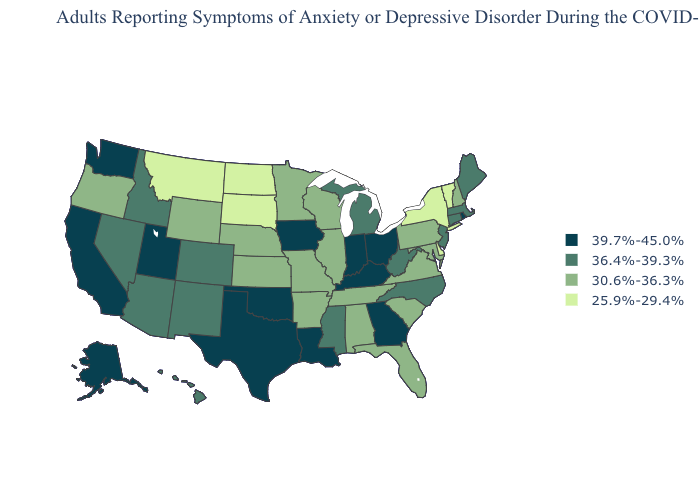Does Florida have the same value as North Dakota?
Answer briefly. No. Name the states that have a value in the range 39.7%-45.0%?
Answer briefly. Alaska, California, Georgia, Indiana, Iowa, Kentucky, Louisiana, Ohio, Oklahoma, Rhode Island, Texas, Utah, Washington. Does the first symbol in the legend represent the smallest category?
Keep it brief. No. Which states have the highest value in the USA?
Answer briefly. Alaska, California, Georgia, Indiana, Iowa, Kentucky, Louisiana, Ohio, Oklahoma, Rhode Island, Texas, Utah, Washington. Name the states that have a value in the range 30.6%-36.3%?
Keep it brief. Alabama, Arkansas, Florida, Illinois, Kansas, Maryland, Minnesota, Missouri, Nebraska, New Hampshire, Oregon, Pennsylvania, South Carolina, Tennessee, Virginia, Wisconsin, Wyoming. What is the value of Kansas?
Write a very short answer. 30.6%-36.3%. Among the states that border Virginia , does Kentucky have the lowest value?
Keep it brief. No. Among the states that border Wisconsin , which have the lowest value?
Short answer required. Illinois, Minnesota. What is the value of Delaware?
Answer briefly. 25.9%-29.4%. What is the value of New York?
Answer briefly. 25.9%-29.4%. Name the states that have a value in the range 25.9%-29.4%?
Quick response, please. Delaware, Montana, New York, North Dakota, South Dakota, Vermont. Does Massachusetts have the highest value in the Northeast?
Give a very brief answer. No. How many symbols are there in the legend?
Short answer required. 4. What is the value of Hawaii?
Concise answer only. 36.4%-39.3%. What is the value of Massachusetts?
Write a very short answer. 36.4%-39.3%. 